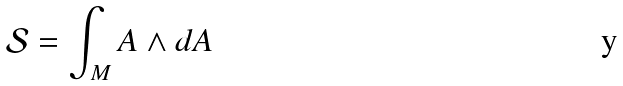<formula> <loc_0><loc_0><loc_500><loc_500>\mathcal { S } = \int _ { M } A \wedge d A</formula> 